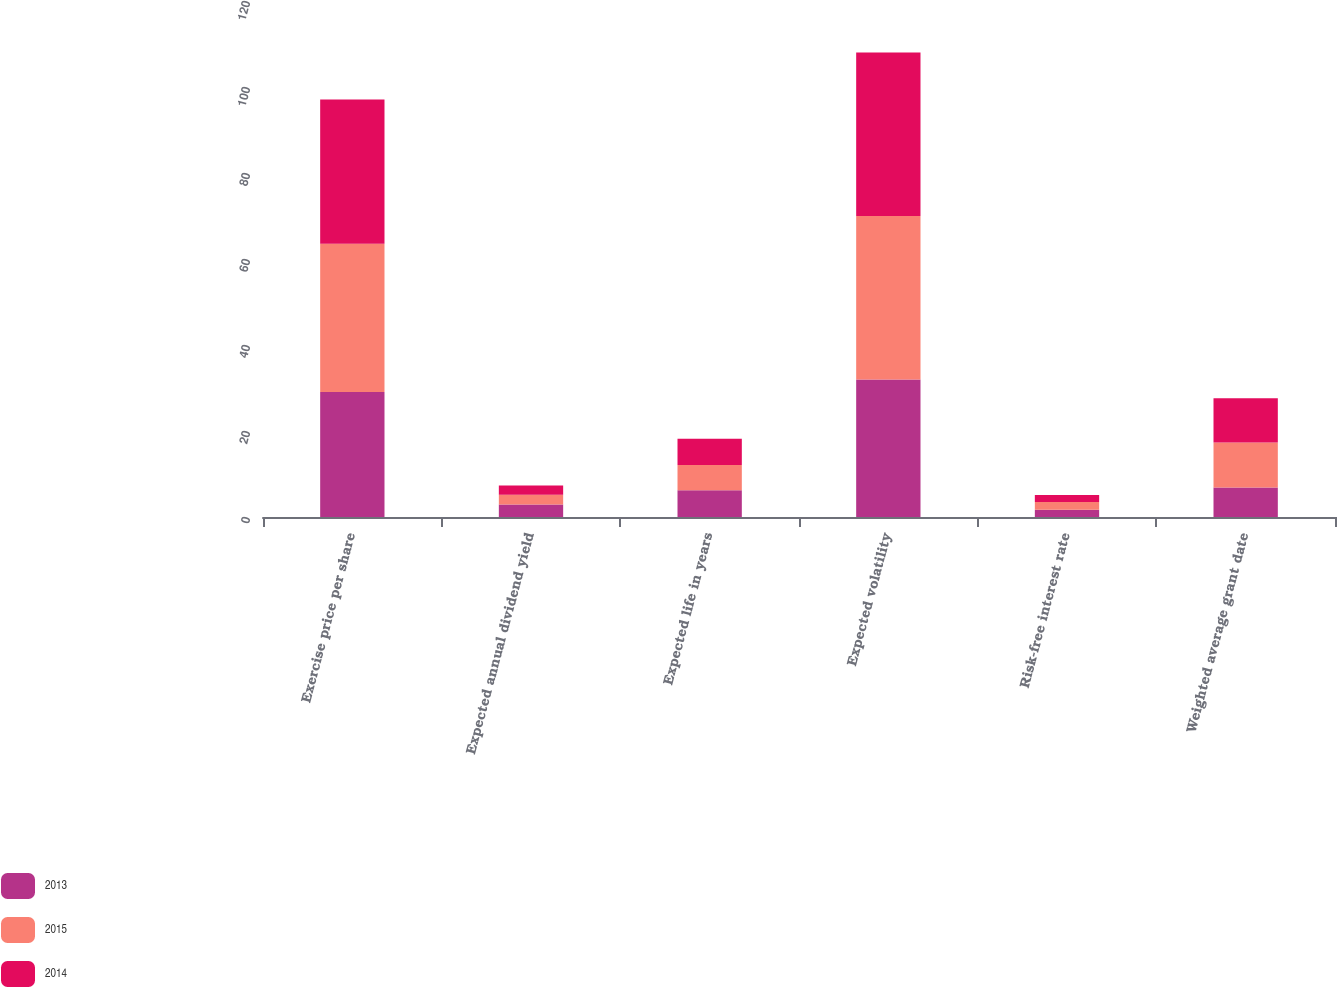Convert chart to OTSL. <chart><loc_0><loc_0><loc_500><loc_500><stacked_bar_chart><ecel><fcel>Exercise price per share<fcel>Expected annual dividend yield<fcel>Expected life in years<fcel>Expected volatility<fcel>Risk-free interest rate<fcel>Weighted average grant date<nl><fcel>2013<fcel>29.06<fcel>2.9<fcel>6.2<fcel>32<fcel>1.7<fcel>6.84<nl><fcel>2015<fcel>34.49<fcel>2.3<fcel>5.9<fcel>38<fcel>1.8<fcel>10.5<nl><fcel>2014<fcel>33.54<fcel>2.1<fcel>6.1<fcel>38<fcel>1.6<fcel>10.25<nl></chart> 